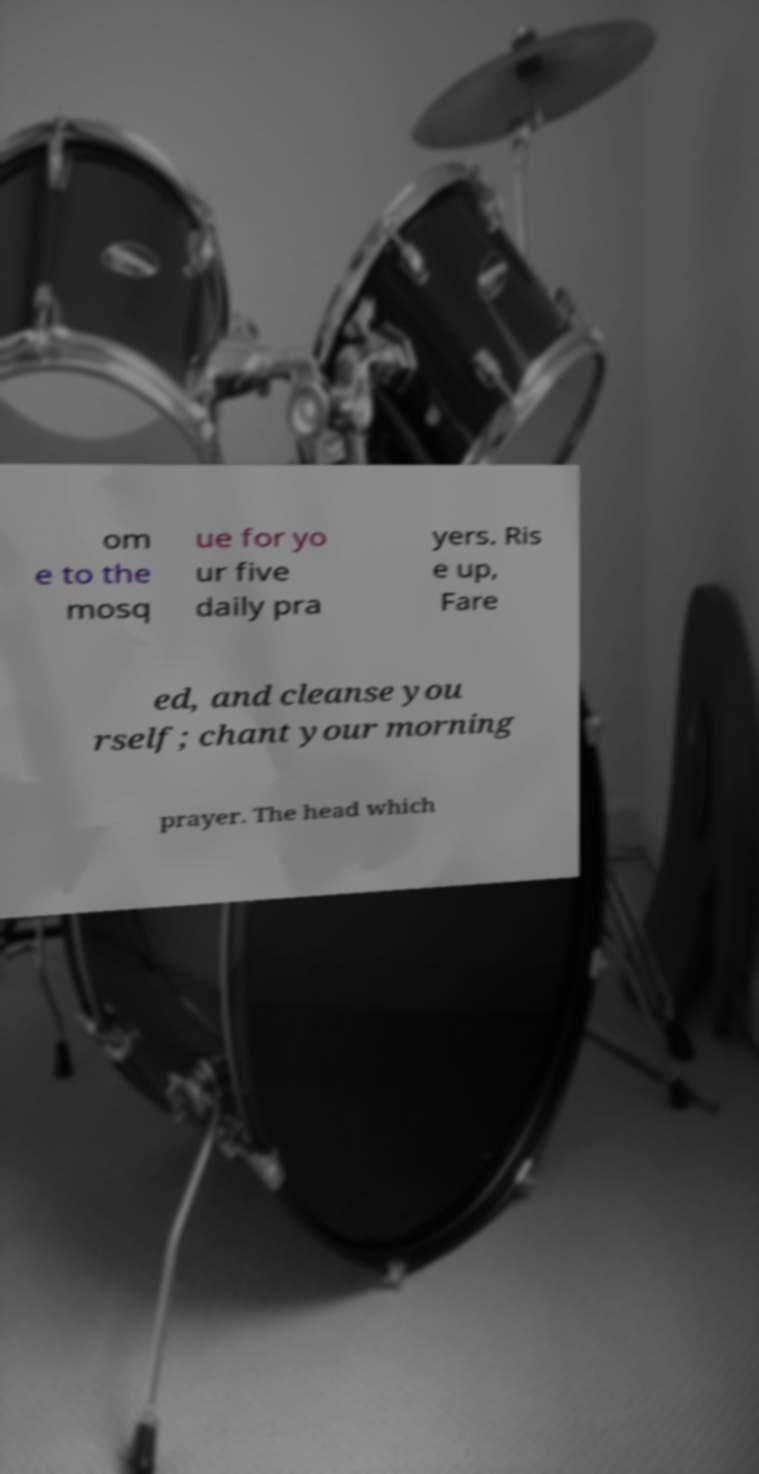For documentation purposes, I need the text within this image transcribed. Could you provide that? om e to the mosq ue for yo ur five daily pra yers. Ris e up, Fare ed, and cleanse you rself; chant your morning prayer. The head which 